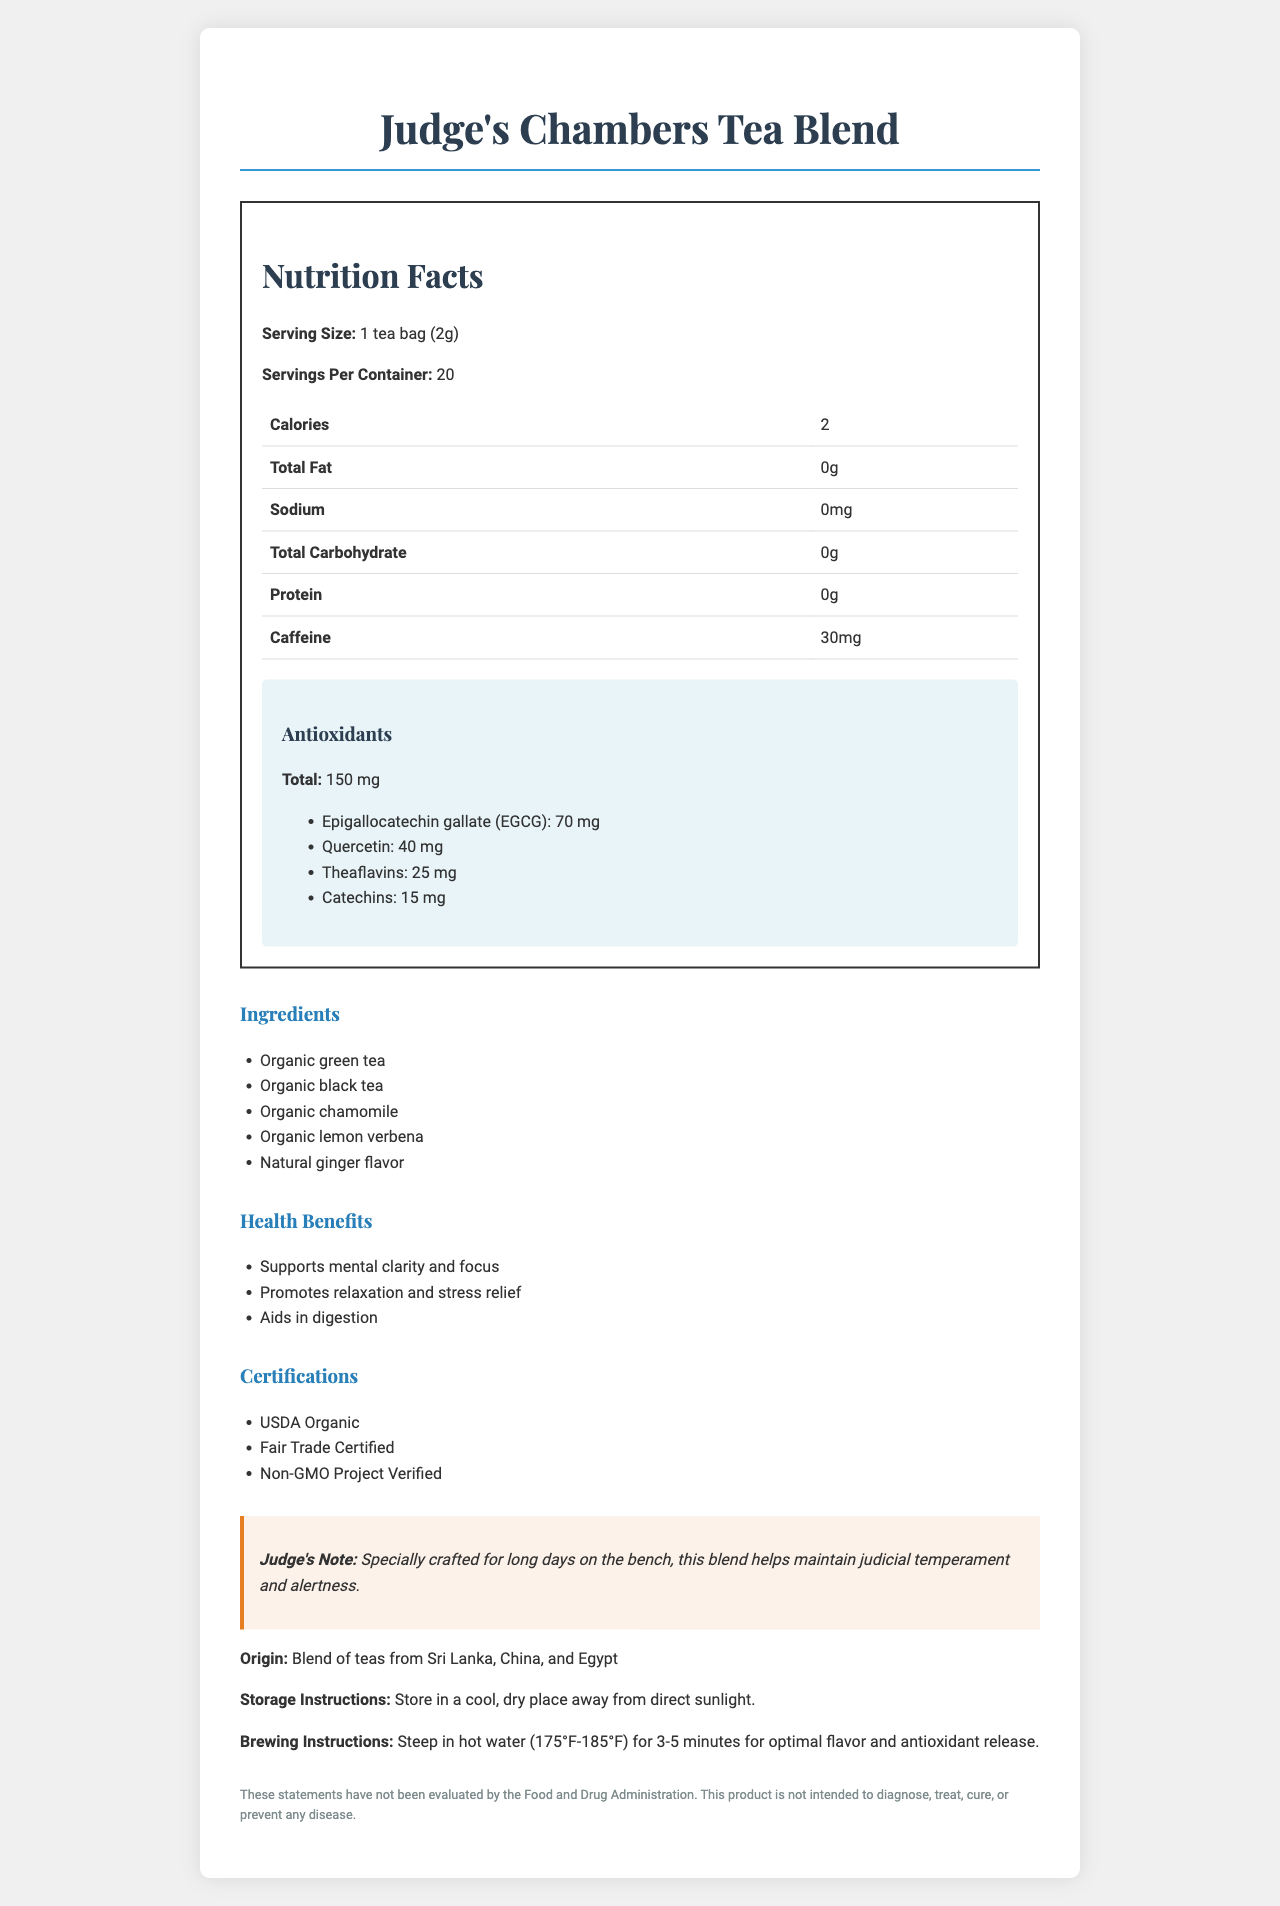what is the serving size for the Judge's Chambers Tea Blend? The serving size is explicitly stated as "1 tea bag (2g)" in the document.
Answer: 1 tea bag (2g) how many servings are there per container? The document mentions that there are 20 servings per container.
Answer: 20 what is the calorie count per serving? The document states that each serving contains 2 calories.
Answer: 2 what is the total amount of antioxidants per serving in mg? The document specifies there are 150 mg of antioxidants per serving.
Answer: 150 mg what are the main ingredients in the tea blend? The main ingredients are listed: Organic green tea, Organic black tea, Organic chamomile, Organic lemon verbena, and Natural ginger flavor.
Answer: Organic green tea, Organic black tea, Organic chamomile, Organic lemon verbena, Natural ginger flavor what types of certifications does the tea blend have? The document lists the certifications as USDA Organic, Fair Trade Certified, and Non-GMO Project Verified.
Answer: USDA Organic, Fair Trade Certified, Non-GMO Project Verified how much caffeine is in one serving of the tea? The document specifies that there are 30 mg of caffeine per serving.
Answer: 30 mg describe the health benefits of Judge's Chambers Tea Blend. The health benefits listed are: Supports mental clarity and focus, Promotes relaxation and stress relief, and Aids in digestion.
Answer: Supports mental clarity and focus, Promotes relaxation and stress relief, Aids in digestion what are the exact amounts of each antioxidant in the tea blend? The document details the amounts of each antioxidant: EGCG (70 mg), Quercetin (40 mg), Theaflavins (25 mg), and Catechins (15 mg).
Answer: EGCG: 70 mg, Quercetin: 40 mg, Theaflavins: 25 mg, Catechins: 15 mg where does the tea blend originate? The document states that the blend originates from Sri Lanka, China, and Egypt.
Answer: Blend of teas from Sri Lanka, China, and Egypt what are the storage instructions for the tea? The storage instructions are provided as: Store in a cool, dry place away from direct sunlight.
Answer: Store in a cool, dry place away from direct sunlight. multiple_choice: which antioxidant is present in the highest amount in the tea blend? 1. EGCG 2. Quercetin 3. Theaflavins 4. Catechins EGCG is present in the highest amount at 70 mg.
Answer: 1 multiple_choice: how many mg of Theaflavins are in one serving of the tea blend? A. 15 mg B. 25 mg C. 40 mg D. 70 mg The document states there are 25 mg of Theaflavins per serving.
Answer: B yes_no: is the tea a good source of protein? The protein content is listed as 0g, indicating it is not a source of protein.
Answer: No summarize the main idea of the document. The document provides comprehensive details about the Judge's Chambers Tea Blend, focusing on its nutritional benefits, ingredients, certifications, and special features designed to support health and well-being.
Answer: The Judge's Chambers Tea Blend is a specialty tea with low calorie content, high antioxidant content, and several health benefits. It contains natural ingredients and is certified organic, Fair Trade, and non-GMO. The document includes nutrition facts, ingredient list, health benefits, brewing and storage instructions, and a note from Judge Richard G. Kopf endorsing the product. can this tea blend cure any diseases? The legal disclaimer explicitly states that the product is not intended to diagnose, treat, cure, or prevent any disease.
Answer: Not enough information 